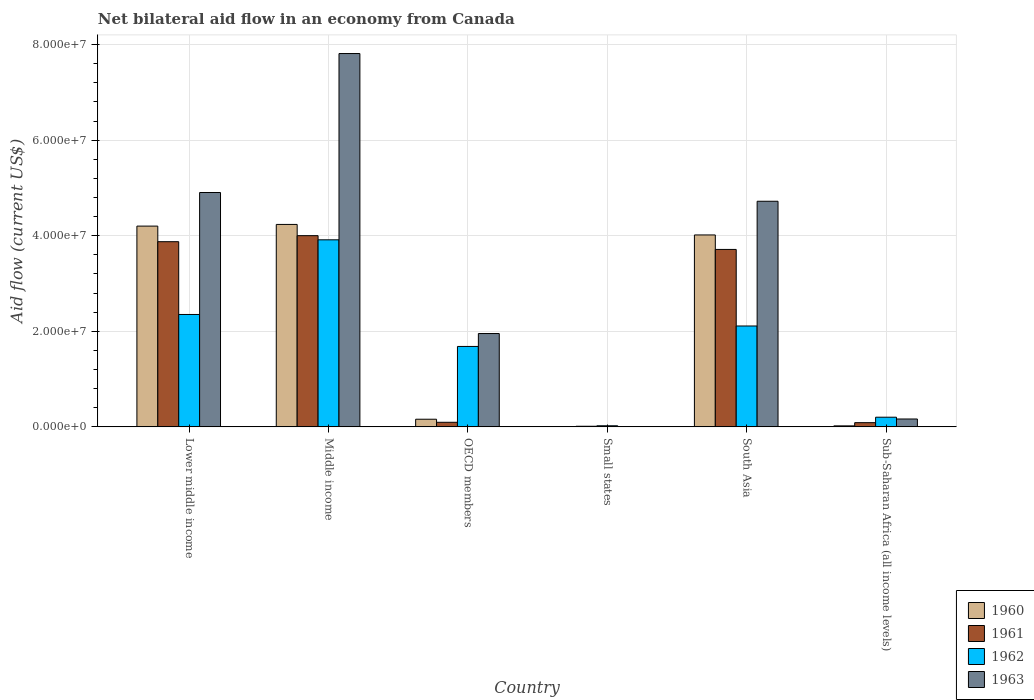How many different coloured bars are there?
Ensure brevity in your answer.  4. How many groups of bars are there?
Give a very brief answer. 6. Are the number of bars on each tick of the X-axis equal?
Provide a succinct answer. Yes. How many bars are there on the 1st tick from the left?
Provide a short and direct response. 4. How many bars are there on the 3rd tick from the right?
Offer a terse response. 4. Across all countries, what is the maximum net bilateral aid flow in 1962?
Ensure brevity in your answer.  3.91e+07. In which country was the net bilateral aid flow in 1960 maximum?
Your response must be concise. Middle income. In which country was the net bilateral aid flow in 1962 minimum?
Offer a terse response. Small states. What is the total net bilateral aid flow in 1961 in the graph?
Offer a terse response. 1.18e+08. What is the difference between the net bilateral aid flow in 1962 in South Asia and that in Sub-Saharan Africa (all income levels)?
Keep it short and to the point. 1.91e+07. What is the difference between the net bilateral aid flow in 1960 in Sub-Saharan Africa (all income levels) and the net bilateral aid flow in 1961 in OECD members?
Provide a short and direct response. -7.50e+05. What is the average net bilateral aid flow in 1962 per country?
Make the answer very short. 1.71e+07. What is the ratio of the net bilateral aid flow in 1962 in Lower middle income to that in OECD members?
Your response must be concise. 1.4. Is the difference between the net bilateral aid flow in 1960 in Lower middle income and Small states greater than the difference between the net bilateral aid flow in 1961 in Lower middle income and Small states?
Offer a terse response. Yes. What is the difference between the highest and the second highest net bilateral aid flow in 1960?
Provide a succinct answer. 2.20e+06. What is the difference between the highest and the lowest net bilateral aid flow in 1961?
Your response must be concise. 3.99e+07. Is it the case that in every country, the sum of the net bilateral aid flow in 1963 and net bilateral aid flow in 1960 is greater than the sum of net bilateral aid flow in 1962 and net bilateral aid flow in 1961?
Ensure brevity in your answer.  No. What does the 1st bar from the left in South Asia represents?
Offer a terse response. 1960. Is it the case that in every country, the sum of the net bilateral aid flow in 1963 and net bilateral aid flow in 1962 is greater than the net bilateral aid flow in 1961?
Give a very brief answer. Yes. How many countries are there in the graph?
Provide a short and direct response. 6. What is the difference between two consecutive major ticks on the Y-axis?
Offer a very short reply. 2.00e+07. Are the values on the major ticks of Y-axis written in scientific E-notation?
Your response must be concise. Yes. Does the graph contain any zero values?
Provide a short and direct response. No. Does the graph contain grids?
Your answer should be very brief. Yes. Where does the legend appear in the graph?
Make the answer very short. Bottom right. What is the title of the graph?
Your answer should be compact. Net bilateral aid flow in an economy from Canada. What is the Aid flow (current US$) of 1960 in Lower middle income?
Keep it short and to the point. 4.20e+07. What is the Aid flow (current US$) of 1961 in Lower middle income?
Your answer should be very brief. 3.88e+07. What is the Aid flow (current US$) of 1962 in Lower middle income?
Your response must be concise. 2.35e+07. What is the Aid flow (current US$) in 1963 in Lower middle income?
Offer a very short reply. 4.90e+07. What is the Aid flow (current US$) of 1960 in Middle income?
Ensure brevity in your answer.  4.24e+07. What is the Aid flow (current US$) in 1961 in Middle income?
Make the answer very short. 4.00e+07. What is the Aid flow (current US$) in 1962 in Middle income?
Your answer should be very brief. 3.91e+07. What is the Aid flow (current US$) in 1963 in Middle income?
Make the answer very short. 7.81e+07. What is the Aid flow (current US$) in 1960 in OECD members?
Provide a short and direct response. 1.60e+06. What is the Aid flow (current US$) in 1961 in OECD members?
Provide a short and direct response. 9.60e+05. What is the Aid flow (current US$) of 1962 in OECD members?
Provide a succinct answer. 1.68e+07. What is the Aid flow (current US$) in 1963 in OECD members?
Your answer should be compact. 1.95e+07. What is the Aid flow (current US$) in 1961 in Small states?
Give a very brief answer. 1.30e+05. What is the Aid flow (current US$) of 1960 in South Asia?
Make the answer very short. 4.02e+07. What is the Aid flow (current US$) in 1961 in South Asia?
Offer a very short reply. 3.71e+07. What is the Aid flow (current US$) of 1962 in South Asia?
Your response must be concise. 2.11e+07. What is the Aid flow (current US$) of 1963 in South Asia?
Offer a terse response. 4.72e+07. What is the Aid flow (current US$) of 1960 in Sub-Saharan Africa (all income levels)?
Offer a terse response. 2.10e+05. What is the Aid flow (current US$) in 1961 in Sub-Saharan Africa (all income levels)?
Make the answer very short. 8.80e+05. What is the Aid flow (current US$) in 1962 in Sub-Saharan Africa (all income levels)?
Offer a terse response. 2.02e+06. What is the Aid flow (current US$) of 1963 in Sub-Saharan Africa (all income levels)?
Your response must be concise. 1.65e+06. Across all countries, what is the maximum Aid flow (current US$) of 1960?
Provide a succinct answer. 4.24e+07. Across all countries, what is the maximum Aid flow (current US$) of 1961?
Give a very brief answer. 4.00e+07. Across all countries, what is the maximum Aid flow (current US$) in 1962?
Keep it short and to the point. 3.91e+07. Across all countries, what is the maximum Aid flow (current US$) of 1963?
Give a very brief answer. 7.81e+07. Across all countries, what is the minimum Aid flow (current US$) of 1962?
Your answer should be compact. 2.30e+05. Across all countries, what is the minimum Aid flow (current US$) in 1963?
Provide a short and direct response. 3.00e+04. What is the total Aid flow (current US$) of 1960 in the graph?
Ensure brevity in your answer.  1.26e+08. What is the total Aid flow (current US$) of 1961 in the graph?
Give a very brief answer. 1.18e+08. What is the total Aid flow (current US$) of 1962 in the graph?
Your response must be concise. 1.03e+08. What is the total Aid flow (current US$) of 1963 in the graph?
Give a very brief answer. 1.96e+08. What is the difference between the Aid flow (current US$) of 1960 in Lower middle income and that in Middle income?
Your answer should be very brief. -3.50e+05. What is the difference between the Aid flow (current US$) in 1961 in Lower middle income and that in Middle income?
Keep it short and to the point. -1.26e+06. What is the difference between the Aid flow (current US$) of 1962 in Lower middle income and that in Middle income?
Give a very brief answer. -1.56e+07. What is the difference between the Aid flow (current US$) in 1963 in Lower middle income and that in Middle income?
Provide a short and direct response. -2.91e+07. What is the difference between the Aid flow (current US$) of 1960 in Lower middle income and that in OECD members?
Provide a succinct answer. 4.04e+07. What is the difference between the Aid flow (current US$) in 1961 in Lower middle income and that in OECD members?
Keep it short and to the point. 3.78e+07. What is the difference between the Aid flow (current US$) of 1962 in Lower middle income and that in OECD members?
Your answer should be very brief. 6.69e+06. What is the difference between the Aid flow (current US$) of 1963 in Lower middle income and that in OECD members?
Offer a very short reply. 2.95e+07. What is the difference between the Aid flow (current US$) in 1960 in Lower middle income and that in Small states?
Provide a short and direct response. 4.20e+07. What is the difference between the Aid flow (current US$) of 1961 in Lower middle income and that in Small states?
Your answer should be compact. 3.86e+07. What is the difference between the Aid flow (current US$) of 1962 in Lower middle income and that in Small states?
Offer a very short reply. 2.33e+07. What is the difference between the Aid flow (current US$) in 1963 in Lower middle income and that in Small states?
Keep it short and to the point. 4.90e+07. What is the difference between the Aid flow (current US$) in 1960 in Lower middle income and that in South Asia?
Give a very brief answer. 1.85e+06. What is the difference between the Aid flow (current US$) of 1961 in Lower middle income and that in South Asia?
Your answer should be compact. 1.62e+06. What is the difference between the Aid flow (current US$) of 1962 in Lower middle income and that in South Asia?
Keep it short and to the point. 2.41e+06. What is the difference between the Aid flow (current US$) in 1963 in Lower middle income and that in South Asia?
Your response must be concise. 1.83e+06. What is the difference between the Aid flow (current US$) of 1960 in Lower middle income and that in Sub-Saharan Africa (all income levels)?
Provide a short and direct response. 4.18e+07. What is the difference between the Aid flow (current US$) of 1961 in Lower middle income and that in Sub-Saharan Africa (all income levels)?
Offer a terse response. 3.79e+07. What is the difference between the Aid flow (current US$) of 1962 in Lower middle income and that in Sub-Saharan Africa (all income levels)?
Keep it short and to the point. 2.15e+07. What is the difference between the Aid flow (current US$) in 1963 in Lower middle income and that in Sub-Saharan Africa (all income levels)?
Your response must be concise. 4.74e+07. What is the difference between the Aid flow (current US$) in 1960 in Middle income and that in OECD members?
Offer a terse response. 4.08e+07. What is the difference between the Aid flow (current US$) in 1961 in Middle income and that in OECD members?
Keep it short and to the point. 3.90e+07. What is the difference between the Aid flow (current US$) in 1962 in Middle income and that in OECD members?
Your response must be concise. 2.23e+07. What is the difference between the Aid flow (current US$) in 1963 in Middle income and that in OECD members?
Ensure brevity in your answer.  5.86e+07. What is the difference between the Aid flow (current US$) in 1960 in Middle income and that in Small states?
Provide a short and direct response. 4.23e+07. What is the difference between the Aid flow (current US$) of 1961 in Middle income and that in Small states?
Provide a succinct answer. 3.99e+07. What is the difference between the Aid flow (current US$) in 1962 in Middle income and that in Small states?
Offer a terse response. 3.89e+07. What is the difference between the Aid flow (current US$) in 1963 in Middle income and that in Small states?
Offer a very short reply. 7.81e+07. What is the difference between the Aid flow (current US$) of 1960 in Middle income and that in South Asia?
Your answer should be very brief. 2.20e+06. What is the difference between the Aid flow (current US$) in 1961 in Middle income and that in South Asia?
Ensure brevity in your answer.  2.88e+06. What is the difference between the Aid flow (current US$) in 1962 in Middle income and that in South Asia?
Ensure brevity in your answer.  1.80e+07. What is the difference between the Aid flow (current US$) of 1963 in Middle income and that in South Asia?
Your response must be concise. 3.09e+07. What is the difference between the Aid flow (current US$) in 1960 in Middle income and that in Sub-Saharan Africa (all income levels)?
Provide a succinct answer. 4.22e+07. What is the difference between the Aid flow (current US$) in 1961 in Middle income and that in Sub-Saharan Africa (all income levels)?
Offer a terse response. 3.91e+07. What is the difference between the Aid flow (current US$) of 1962 in Middle income and that in Sub-Saharan Africa (all income levels)?
Your answer should be compact. 3.71e+07. What is the difference between the Aid flow (current US$) of 1963 in Middle income and that in Sub-Saharan Africa (all income levels)?
Provide a short and direct response. 7.65e+07. What is the difference between the Aid flow (current US$) in 1960 in OECD members and that in Small states?
Your answer should be very brief. 1.58e+06. What is the difference between the Aid flow (current US$) of 1961 in OECD members and that in Small states?
Give a very brief answer. 8.30e+05. What is the difference between the Aid flow (current US$) in 1962 in OECD members and that in Small states?
Give a very brief answer. 1.66e+07. What is the difference between the Aid flow (current US$) in 1963 in OECD members and that in Small states?
Ensure brevity in your answer.  1.95e+07. What is the difference between the Aid flow (current US$) of 1960 in OECD members and that in South Asia?
Ensure brevity in your answer.  -3.86e+07. What is the difference between the Aid flow (current US$) of 1961 in OECD members and that in South Asia?
Ensure brevity in your answer.  -3.62e+07. What is the difference between the Aid flow (current US$) of 1962 in OECD members and that in South Asia?
Your answer should be very brief. -4.28e+06. What is the difference between the Aid flow (current US$) in 1963 in OECD members and that in South Asia?
Keep it short and to the point. -2.77e+07. What is the difference between the Aid flow (current US$) of 1960 in OECD members and that in Sub-Saharan Africa (all income levels)?
Keep it short and to the point. 1.39e+06. What is the difference between the Aid flow (current US$) of 1961 in OECD members and that in Sub-Saharan Africa (all income levels)?
Keep it short and to the point. 8.00e+04. What is the difference between the Aid flow (current US$) in 1962 in OECD members and that in Sub-Saharan Africa (all income levels)?
Your response must be concise. 1.48e+07. What is the difference between the Aid flow (current US$) in 1963 in OECD members and that in Sub-Saharan Africa (all income levels)?
Your answer should be very brief. 1.79e+07. What is the difference between the Aid flow (current US$) of 1960 in Small states and that in South Asia?
Make the answer very short. -4.01e+07. What is the difference between the Aid flow (current US$) of 1961 in Small states and that in South Asia?
Keep it short and to the point. -3.70e+07. What is the difference between the Aid flow (current US$) of 1962 in Small states and that in South Asia?
Keep it short and to the point. -2.09e+07. What is the difference between the Aid flow (current US$) of 1963 in Small states and that in South Asia?
Your answer should be compact. -4.72e+07. What is the difference between the Aid flow (current US$) of 1961 in Small states and that in Sub-Saharan Africa (all income levels)?
Your answer should be compact. -7.50e+05. What is the difference between the Aid flow (current US$) in 1962 in Small states and that in Sub-Saharan Africa (all income levels)?
Provide a short and direct response. -1.79e+06. What is the difference between the Aid flow (current US$) in 1963 in Small states and that in Sub-Saharan Africa (all income levels)?
Provide a short and direct response. -1.62e+06. What is the difference between the Aid flow (current US$) in 1960 in South Asia and that in Sub-Saharan Africa (all income levels)?
Offer a terse response. 4.00e+07. What is the difference between the Aid flow (current US$) of 1961 in South Asia and that in Sub-Saharan Africa (all income levels)?
Your response must be concise. 3.62e+07. What is the difference between the Aid flow (current US$) of 1962 in South Asia and that in Sub-Saharan Africa (all income levels)?
Your answer should be compact. 1.91e+07. What is the difference between the Aid flow (current US$) in 1963 in South Asia and that in Sub-Saharan Africa (all income levels)?
Make the answer very short. 4.56e+07. What is the difference between the Aid flow (current US$) in 1960 in Lower middle income and the Aid flow (current US$) in 1961 in Middle income?
Offer a very short reply. 2.00e+06. What is the difference between the Aid flow (current US$) in 1960 in Lower middle income and the Aid flow (current US$) in 1962 in Middle income?
Offer a terse response. 2.87e+06. What is the difference between the Aid flow (current US$) of 1960 in Lower middle income and the Aid flow (current US$) of 1963 in Middle income?
Give a very brief answer. -3.61e+07. What is the difference between the Aid flow (current US$) of 1961 in Lower middle income and the Aid flow (current US$) of 1962 in Middle income?
Offer a very short reply. -3.90e+05. What is the difference between the Aid flow (current US$) in 1961 in Lower middle income and the Aid flow (current US$) in 1963 in Middle income?
Provide a short and direct response. -3.94e+07. What is the difference between the Aid flow (current US$) in 1962 in Lower middle income and the Aid flow (current US$) in 1963 in Middle income?
Your answer should be very brief. -5.46e+07. What is the difference between the Aid flow (current US$) in 1960 in Lower middle income and the Aid flow (current US$) in 1961 in OECD members?
Ensure brevity in your answer.  4.10e+07. What is the difference between the Aid flow (current US$) in 1960 in Lower middle income and the Aid flow (current US$) in 1962 in OECD members?
Provide a short and direct response. 2.52e+07. What is the difference between the Aid flow (current US$) of 1960 in Lower middle income and the Aid flow (current US$) of 1963 in OECD members?
Your answer should be very brief. 2.25e+07. What is the difference between the Aid flow (current US$) in 1961 in Lower middle income and the Aid flow (current US$) in 1962 in OECD members?
Offer a terse response. 2.19e+07. What is the difference between the Aid flow (current US$) in 1961 in Lower middle income and the Aid flow (current US$) in 1963 in OECD members?
Give a very brief answer. 1.92e+07. What is the difference between the Aid flow (current US$) of 1962 in Lower middle income and the Aid flow (current US$) of 1963 in OECD members?
Provide a short and direct response. 3.99e+06. What is the difference between the Aid flow (current US$) in 1960 in Lower middle income and the Aid flow (current US$) in 1961 in Small states?
Give a very brief answer. 4.19e+07. What is the difference between the Aid flow (current US$) of 1960 in Lower middle income and the Aid flow (current US$) of 1962 in Small states?
Your answer should be very brief. 4.18e+07. What is the difference between the Aid flow (current US$) in 1960 in Lower middle income and the Aid flow (current US$) in 1963 in Small states?
Provide a short and direct response. 4.20e+07. What is the difference between the Aid flow (current US$) of 1961 in Lower middle income and the Aid flow (current US$) of 1962 in Small states?
Ensure brevity in your answer.  3.85e+07. What is the difference between the Aid flow (current US$) in 1961 in Lower middle income and the Aid flow (current US$) in 1963 in Small states?
Offer a terse response. 3.87e+07. What is the difference between the Aid flow (current US$) in 1962 in Lower middle income and the Aid flow (current US$) in 1963 in Small states?
Offer a terse response. 2.35e+07. What is the difference between the Aid flow (current US$) of 1960 in Lower middle income and the Aid flow (current US$) of 1961 in South Asia?
Provide a succinct answer. 4.88e+06. What is the difference between the Aid flow (current US$) of 1960 in Lower middle income and the Aid flow (current US$) of 1962 in South Asia?
Your answer should be compact. 2.09e+07. What is the difference between the Aid flow (current US$) of 1960 in Lower middle income and the Aid flow (current US$) of 1963 in South Asia?
Make the answer very short. -5.20e+06. What is the difference between the Aid flow (current US$) of 1961 in Lower middle income and the Aid flow (current US$) of 1962 in South Asia?
Provide a short and direct response. 1.76e+07. What is the difference between the Aid flow (current US$) of 1961 in Lower middle income and the Aid flow (current US$) of 1963 in South Asia?
Keep it short and to the point. -8.46e+06. What is the difference between the Aid flow (current US$) of 1962 in Lower middle income and the Aid flow (current US$) of 1963 in South Asia?
Offer a terse response. -2.37e+07. What is the difference between the Aid flow (current US$) of 1960 in Lower middle income and the Aid flow (current US$) of 1961 in Sub-Saharan Africa (all income levels)?
Provide a short and direct response. 4.11e+07. What is the difference between the Aid flow (current US$) in 1960 in Lower middle income and the Aid flow (current US$) in 1962 in Sub-Saharan Africa (all income levels)?
Your answer should be very brief. 4.00e+07. What is the difference between the Aid flow (current US$) in 1960 in Lower middle income and the Aid flow (current US$) in 1963 in Sub-Saharan Africa (all income levels)?
Ensure brevity in your answer.  4.04e+07. What is the difference between the Aid flow (current US$) in 1961 in Lower middle income and the Aid flow (current US$) in 1962 in Sub-Saharan Africa (all income levels)?
Offer a terse response. 3.67e+07. What is the difference between the Aid flow (current US$) in 1961 in Lower middle income and the Aid flow (current US$) in 1963 in Sub-Saharan Africa (all income levels)?
Your response must be concise. 3.71e+07. What is the difference between the Aid flow (current US$) of 1962 in Lower middle income and the Aid flow (current US$) of 1963 in Sub-Saharan Africa (all income levels)?
Your answer should be compact. 2.19e+07. What is the difference between the Aid flow (current US$) of 1960 in Middle income and the Aid flow (current US$) of 1961 in OECD members?
Give a very brief answer. 4.14e+07. What is the difference between the Aid flow (current US$) of 1960 in Middle income and the Aid flow (current US$) of 1962 in OECD members?
Offer a very short reply. 2.55e+07. What is the difference between the Aid flow (current US$) in 1960 in Middle income and the Aid flow (current US$) in 1963 in OECD members?
Offer a terse response. 2.28e+07. What is the difference between the Aid flow (current US$) of 1961 in Middle income and the Aid flow (current US$) of 1962 in OECD members?
Provide a short and direct response. 2.32e+07. What is the difference between the Aid flow (current US$) of 1961 in Middle income and the Aid flow (current US$) of 1963 in OECD members?
Ensure brevity in your answer.  2.05e+07. What is the difference between the Aid flow (current US$) of 1962 in Middle income and the Aid flow (current US$) of 1963 in OECD members?
Make the answer very short. 1.96e+07. What is the difference between the Aid flow (current US$) in 1960 in Middle income and the Aid flow (current US$) in 1961 in Small states?
Provide a succinct answer. 4.22e+07. What is the difference between the Aid flow (current US$) in 1960 in Middle income and the Aid flow (current US$) in 1962 in Small states?
Provide a succinct answer. 4.21e+07. What is the difference between the Aid flow (current US$) of 1960 in Middle income and the Aid flow (current US$) of 1963 in Small states?
Your answer should be very brief. 4.23e+07. What is the difference between the Aid flow (current US$) in 1961 in Middle income and the Aid flow (current US$) in 1962 in Small states?
Ensure brevity in your answer.  3.98e+07. What is the difference between the Aid flow (current US$) in 1961 in Middle income and the Aid flow (current US$) in 1963 in Small states?
Provide a succinct answer. 4.00e+07. What is the difference between the Aid flow (current US$) of 1962 in Middle income and the Aid flow (current US$) of 1963 in Small states?
Your answer should be compact. 3.91e+07. What is the difference between the Aid flow (current US$) of 1960 in Middle income and the Aid flow (current US$) of 1961 in South Asia?
Make the answer very short. 5.23e+06. What is the difference between the Aid flow (current US$) in 1960 in Middle income and the Aid flow (current US$) in 1962 in South Asia?
Keep it short and to the point. 2.12e+07. What is the difference between the Aid flow (current US$) in 1960 in Middle income and the Aid flow (current US$) in 1963 in South Asia?
Offer a very short reply. -4.85e+06. What is the difference between the Aid flow (current US$) of 1961 in Middle income and the Aid flow (current US$) of 1962 in South Asia?
Ensure brevity in your answer.  1.89e+07. What is the difference between the Aid flow (current US$) in 1961 in Middle income and the Aid flow (current US$) in 1963 in South Asia?
Give a very brief answer. -7.20e+06. What is the difference between the Aid flow (current US$) in 1962 in Middle income and the Aid flow (current US$) in 1963 in South Asia?
Provide a short and direct response. -8.07e+06. What is the difference between the Aid flow (current US$) of 1960 in Middle income and the Aid flow (current US$) of 1961 in Sub-Saharan Africa (all income levels)?
Your response must be concise. 4.15e+07. What is the difference between the Aid flow (current US$) in 1960 in Middle income and the Aid flow (current US$) in 1962 in Sub-Saharan Africa (all income levels)?
Your answer should be very brief. 4.03e+07. What is the difference between the Aid flow (current US$) of 1960 in Middle income and the Aid flow (current US$) of 1963 in Sub-Saharan Africa (all income levels)?
Make the answer very short. 4.07e+07. What is the difference between the Aid flow (current US$) of 1961 in Middle income and the Aid flow (current US$) of 1962 in Sub-Saharan Africa (all income levels)?
Your answer should be compact. 3.80e+07. What is the difference between the Aid flow (current US$) in 1961 in Middle income and the Aid flow (current US$) in 1963 in Sub-Saharan Africa (all income levels)?
Ensure brevity in your answer.  3.84e+07. What is the difference between the Aid flow (current US$) of 1962 in Middle income and the Aid flow (current US$) of 1963 in Sub-Saharan Africa (all income levels)?
Your answer should be very brief. 3.75e+07. What is the difference between the Aid flow (current US$) in 1960 in OECD members and the Aid flow (current US$) in 1961 in Small states?
Offer a very short reply. 1.47e+06. What is the difference between the Aid flow (current US$) in 1960 in OECD members and the Aid flow (current US$) in 1962 in Small states?
Keep it short and to the point. 1.37e+06. What is the difference between the Aid flow (current US$) of 1960 in OECD members and the Aid flow (current US$) of 1963 in Small states?
Your answer should be very brief. 1.57e+06. What is the difference between the Aid flow (current US$) in 1961 in OECD members and the Aid flow (current US$) in 1962 in Small states?
Your response must be concise. 7.30e+05. What is the difference between the Aid flow (current US$) of 1961 in OECD members and the Aid flow (current US$) of 1963 in Small states?
Your response must be concise. 9.30e+05. What is the difference between the Aid flow (current US$) of 1962 in OECD members and the Aid flow (current US$) of 1963 in Small states?
Your response must be concise. 1.68e+07. What is the difference between the Aid flow (current US$) in 1960 in OECD members and the Aid flow (current US$) in 1961 in South Asia?
Your answer should be compact. -3.55e+07. What is the difference between the Aid flow (current US$) of 1960 in OECD members and the Aid flow (current US$) of 1962 in South Asia?
Ensure brevity in your answer.  -1.95e+07. What is the difference between the Aid flow (current US$) in 1960 in OECD members and the Aid flow (current US$) in 1963 in South Asia?
Give a very brief answer. -4.56e+07. What is the difference between the Aid flow (current US$) of 1961 in OECD members and the Aid flow (current US$) of 1962 in South Asia?
Offer a very short reply. -2.02e+07. What is the difference between the Aid flow (current US$) in 1961 in OECD members and the Aid flow (current US$) in 1963 in South Asia?
Your response must be concise. -4.62e+07. What is the difference between the Aid flow (current US$) in 1962 in OECD members and the Aid flow (current US$) in 1963 in South Asia?
Provide a short and direct response. -3.04e+07. What is the difference between the Aid flow (current US$) of 1960 in OECD members and the Aid flow (current US$) of 1961 in Sub-Saharan Africa (all income levels)?
Give a very brief answer. 7.20e+05. What is the difference between the Aid flow (current US$) in 1960 in OECD members and the Aid flow (current US$) in 1962 in Sub-Saharan Africa (all income levels)?
Your answer should be compact. -4.20e+05. What is the difference between the Aid flow (current US$) of 1960 in OECD members and the Aid flow (current US$) of 1963 in Sub-Saharan Africa (all income levels)?
Your answer should be compact. -5.00e+04. What is the difference between the Aid flow (current US$) of 1961 in OECD members and the Aid flow (current US$) of 1962 in Sub-Saharan Africa (all income levels)?
Give a very brief answer. -1.06e+06. What is the difference between the Aid flow (current US$) of 1961 in OECD members and the Aid flow (current US$) of 1963 in Sub-Saharan Africa (all income levels)?
Your answer should be compact. -6.90e+05. What is the difference between the Aid flow (current US$) in 1962 in OECD members and the Aid flow (current US$) in 1963 in Sub-Saharan Africa (all income levels)?
Provide a succinct answer. 1.52e+07. What is the difference between the Aid flow (current US$) of 1960 in Small states and the Aid flow (current US$) of 1961 in South Asia?
Keep it short and to the point. -3.71e+07. What is the difference between the Aid flow (current US$) of 1960 in Small states and the Aid flow (current US$) of 1962 in South Asia?
Provide a short and direct response. -2.11e+07. What is the difference between the Aid flow (current US$) of 1960 in Small states and the Aid flow (current US$) of 1963 in South Asia?
Your response must be concise. -4.72e+07. What is the difference between the Aid flow (current US$) in 1961 in Small states and the Aid flow (current US$) in 1962 in South Asia?
Offer a terse response. -2.10e+07. What is the difference between the Aid flow (current US$) in 1961 in Small states and the Aid flow (current US$) in 1963 in South Asia?
Provide a short and direct response. -4.71e+07. What is the difference between the Aid flow (current US$) in 1962 in Small states and the Aid flow (current US$) in 1963 in South Asia?
Give a very brief answer. -4.70e+07. What is the difference between the Aid flow (current US$) in 1960 in Small states and the Aid flow (current US$) in 1961 in Sub-Saharan Africa (all income levels)?
Keep it short and to the point. -8.60e+05. What is the difference between the Aid flow (current US$) of 1960 in Small states and the Aid flow (current US$) of 1962 in Sub-Saharan Africa (all income levels)?
Provide a succinct answer. -2.00e+06. What is the difference between the Aid flow (current US$) in 1960 in Small states and the Aid flow (current US$) in 1963 in Sub-Saharan Africa (all income levels)?
Your answer should be compact. -1.63e+06. What is the difference between the Aid flow (current US$) of 1961 in Small states and the Aid flow (current US$) of 1962 in Sub-Saharan Africa (all income levels)?
Your answer should be very brief. -1.89e+06. What is the difference between the Aid flow (current US$) of 1961 in Small states and the Aid flow (current US$) of 1963 in Sub-Saharan Africa (all income levels)?
Provide a short and direct response. -1.52e+06. What is the difference between the Aid flow (current US$) in 1962 in Small states and the Aid flow (current US$) in 1963 in Sub-Saharan Africa (all income levels)?
Offer a very short reply. -1.42e+06. What is the difference between the Aid flow (current US$) in 1960 in South Asia and the Aid flow (current US$) in 1961 in Sub-Saharan Africa (all income levels)?
Keep it short and to the point. 3.93e+07. What is the difference between the Aid flow (current US$) of 1960 in South Asia and the Aid flow (current US$) of 1962 in Sub-Saharan Africa (all income levels)?
Your response must be concise. 3.81e+07. What is the difference between the Aid flow (current US$) of 1960 in South Asia and the Aid flow (current US$) of 1963 in Sub-Saharan Africa (all income levels)?
Your response must be concise. 3.85e+07. What is the difference between the Aid flow (current US$) of 1961 in South Asia and the Aid flow (current US$) of 1962 in Sub-Saharan Africa (all income levels)?
Offer a terse response. 3.51e+07. What is the difference between the Aid flow (current US$) in 1961 in South Asia and the Aid flow (current US$) in 1963 in Sub-Saharan Africa (all income levels)?
Ensure brevity in your answer.  3.55e+07. What is the difference between the Aid flow (current US$) of 1962 in South Asia and the Aid flow (current US$) of 1963 in Sub-Saharan Africa (all income levels)?
Make the answer very short. 1.95e+07. What is the average Aid flow (current US$) in 1960 per country?
Provide a short and direct response. 2.11e+07. What is the average Aid flow (current US$) of 1961 per country?
Offer a very short reply. 1.96e+07. What is the average Aid flow (current US$) in 1962 per country?
Make the answer very short. 1.71e+07. What is the average Aid flow (current US$) in 1963 per country?
Ensure brevity in your answer.  3.26e+07. What is the difference between the Aid flow (current US$) of 1960 and Aid flow (current US$) of 1961 in Lower middle income?
Provide a succinct answer. 3.26e+06. What is the difference between the Aid flow (current US$) of 1960 and Aid flow (current US$) of 1962 in Lower middle income?
Offer a very short reply. 1.85e+07. What is the difference between the Aid flow (current US$) in 1960 and Aid flow (current US$) in 1963 in Lower middle income?
Your answer should be very brief. -7.03e+06. What is the difference between the Aid flow (current US$) in 1961 and Aid flow (current US$) in 1962 in Lower middle income?
Make the answer very short. 1.52e+07. What is the difference between the Aid flow (current US$) of 1961 and Aid flow (current US$) of 1963 in Lower middle income?
Keep it short and to the point. -1.03e+07. What is the difference between the Aid flow (current US$) of 1962 and Aid flow (current US$) of 1963 in Lower middle income?
Provide a succinct answer. -2.55e+07. What is the difference between the Aid flow (current US$) of 1960 and Aid flow (current US$) of 1961 in Middle income?
Offer a very short reply. 2.35e+06. What is the difference between the Aid flow (current US$) of 1960 and Aid flow (current US$) of 1962 in Middle income?
Your answer should be compact. 3.22e+06. What is the difference between the Aid flow (current US$) in 1960 and Aid flow (current US$) in 1963 in Middle income?
Offer a terse response. -3.58e+07. What is the difference between the Aid flow (current US$) in 1961 and Aid flow (current US$) in 1962 in Middle income?
Your response must be concise. 8.70e+05. What is the difference between the Aid flow (current US$) in 1961 and Aid flow (current US$) in 1963 in Middle income?
Keep it short and to the point. -3.81e+07. What is the difference between the Aid flow (current US$) of 1962 and Aid flow (current US$) of 1963 in Middle income?
Make the answer very short. -3.90e+07. What is the difference between the Aid flow (current US$) of 1960 and Aid flow (current US$) of 1961 in OECD members?
Give a very brief answer. 6.40e+05. What is the difference between the Aid flow (current US$) of 1960 and Aid flow (current US$) of 1962 in OECD members?
Give a very brief answer. -1.52e+07. What is the difference between the Aid flow (current US$) of 1960 and Aid flow (current US$) of 1963 in OECD members?
Ensure brevity in your answer.  -1.79e+07. What is the difference between the Aid flow (current US$) of 1961 and Aid flow (current US$) of 1962 in OECD members?
Your response must be concise. -1.59e+07. What is the difference between the Aid flow (current US$) in 1961 and Aid flow (current US$) in 1963 in OECD members?
Provide a short and direct response. -1.86e+07. What is the difference between the Aid flow (current US$) of 1962 and Aid flow (current US$) of 1963 in OECD members?
Offer a very short reply. -2.70e+06. What is the difference between the Aid flow (current US$) in 1960 and Aid flow (current US$) in 1962 in Small states?
Provide a short and direct response. -2.10e+05. What is the difference between the Aid flow (current US$) of 1960 and Aid flow (current US$) of 1963 in Small states?
Your answer should be very brief. -10000. What is the difference between the Aid flow (current US$) in 1960 and Aid flow (current US$) in 1961 in South Asia?
Your answer should be very brief. 3.03e+06. What is the difference between the Aid flow (current US$) of 1960 and Aid flow (current US$) of 1962 in South Asia?
Keep it short and to the point. 1.90e+07. What is the difference between the Aid flow (current US$) of 1960 and Aid flow (current US$) of 1963 in South Asia?
Ensure brevity in your answer.  -7.05e+06. What is the difference between the Aid flow (current US$) in 1961 and Aid flow (current US$) in 1962 in South Asia?
Your answer should be very brief. 1.60e+07. What is the difference between the Aid flow (current US$) in 1961 and Aid flow (current US$) in 1963 in South Asia?
Offer a terse response. -1.01e+07. What is the difference between the Aid flow (current US$) of 1962 and Aid flow (current US$) of 1963 in South Asia?
Offer a very short reply. -2.61e+07. What is the difference between the Aid flow (current US$) of 1960 and Aid flow (current US$) of 1961 in Sub-Saharan Africa (all income levels)?
Offer a very short reply. -6.70e+05. What is the difference between the Aid flow (current US$) in 1960 and Aid flow (current US$) in 1962 in Sub-Saharan Africa (all income levels)?
Your answer should be compact. -1.81e+06. What is the difference between the Aid flow (current US$) of 1960 and Aid flow (current US$) of 1963 in Sub-Saharan Africa (all income levels)?
Offer a very short reply. -1.44e+06. What is the difference between the Aid flow (current US$) of 1961 and Aid flow (current US$) of 1962 in Sub-Saharan Africa (all income levels)?
Your response must be concise. -1.14e+06. What is the difference between the Aid flow (current US$) in 1961 and Aid flow (current US$) in 1963 in Sub-Saharan Africa (all income levels)?
Offer a terse response. -7.70e+05. What is the ratio of the Aid flow (current US$) in 1961 in Lower middle income to that in Middle income?
Ensure brevity in your answer.  0.97. What is the ratio of the Aid flow (current US$) of 1962 in Lower middle income to that in Middle income?
Keep it short and to the point. 0.6. What is the ratio of the Aid flow (current US$) in 1963 in Lower middle income to that in Middle income?
Give a very brief answer. 0.63. What is the ratio of the Aid flow (current US$) in 1960 in Lower middle income to that in OECD members?
Your answer should be compact. 26.26. What is the ratio of the Aid flow (current US$) of 1961 in Lower middle income to that in OECD members?
Give a very brief answer. 40.36. What is the ratio of the Aid flow (current US$) of 1962 in Lower middle income to that in OECD members?
Ensure brevity in your answer.  1.4. What is the ratio of the Aid flow (current US$) of 1963 in Lower middle income to that in OECD members?
Make the answer very short. 2.51. What is the ratio of the Aid flow (current US$) in 1960 in Lower middle income to that in Small states?
Keep it short and to the point. 2100.5. What is the ratio of the Aid flow (current US$) of 1961 in Lower middle income to that in Small states?
Give a very brief answer. 298.08. What is the ratio of the Aid flow (current US$) in 1962 in Lower middle income to that in Small states?
Provide a succinct answer. 102.26. What is the ratio of the Aid flow (current US$) in 1963 in Lower middle income to that in Small states?
Give a very brief answer. 1634.67. What is the ratio of the Aid flow (current US$) in 1960 in Lower middle income to that in South Asia?
Provide a succinct answer. 1.05. What is the ratio of the Aid flow (current US$) of 1961 in Lower middle income to that in South Asia?
Provide a succinct answer. 1.04. What is the ratio of the Aid flow (current US$) of 1962 in Lower middle income to that in South Asia?
Provide a succinct answer. 1.11. What is the ratio of the Aid flow (current US$) of 1963 in Lower middle income to that in South Asia?
Give a very brief answer. 1.04. What is the ratio of the Aid flow (current US$) of 1960 in Lower middle income to that in Sub-Saharan Africa (all income levels)?
Offer a very short reply. 200.05. What is the ratio of the Aid flow (current US$) in 1961 in Lower middle income to that in Sub-Saharan Africa (all income levels)?
Provide a succinct answer. 44.03. What is the ratio of the Aid flow (current US$) in 1962 in Lower middle income to that in Sub-Saharan Africa (all income levels)?
Ensure brevity in your answer.  11.64. What is the ratio of the Aid flow (current US$) in 1963 in Lower middle income to that in Sub-Saharan Africa (all income levels)?
Give a very brief answer. 29.72. What is the ratio of the Aid flow (current US$) in 1960 in Middle income to that in OECD members?
Provide a succinct answer. 26.48. What is the ratio of the Aid flow (current US$) of 1961 in Middle income to that in OECD members?
Offer a terse response. 41.68. What is the ratio of the Aid flow (current US$) in 1962 in Middle income to that in OECD members?
Offer a very short reply. 2.33. What is the ratio of the Aid flow (current US$) of 1960 in Middle income to that in Small states?
Provide a succinct answer. 2118. What is the ratio of the Aid flow (current US$) of 1961 in Middle income to that in Small states?
Offer a very short reply. 307.77. What is the ratio of the Aid flow (current US$) in 1962 in Middle income to that in Small states?
Offer a very short reply. 170.17. What is the ratio of the Aid flow (current US$) in 1963 in Middle income to that in Small states?
Your response must be concise. 2604. What is the ratio of the Aid flow (current US$) of 1960 in Middle income to that in South Asia?
Keep it short and to the point. 1.05. What is the ratio of the Aid flow (current US$) in 1961 in Middle income to that in South Asia?
Ensure brevity in your answer.  1.08. What is the ratio of the Aid flow (current US$) in 1962 in Middle income to that in South Asia?
Provide a succinct answer. 1.85. What is the ratio of the Aid flow (current US$) in 1963 in Middle income to that in South Asia?
Give a very brief answer. 1.65. What is the ratio of the Aid flow (current US$) in 1960 in Middle income to that in Sub-Saharan Africa (all income levels)?
Your answer should be compact. 201.71. What is the ratio of the Aid flow (current US$) of 1961 in Middle income to that in Sub-Saharan Africa (all income levels)?
Keep it short and to the point. 45.47. What is the ratio of the Aid flow (current US$) of 1962 in Middle income to that in Sub-Saharan Africa (all income levels)?
Keep it short and to the point. 19.38. What is the ratio of the Aid flow (current US$) of 1963 in Middle income to that in Sub-Saharan Africa (all income levels)?
Provide a succinct answer. 47.35. What is the ratio of the Aid flow (current US$) in 1960 in OECD members to that in Small states?
Keep it short and to the point. 80. What is the ratio of the Aid flow (current US$) in 1961 in OECD members to that in Small states?
Provide a succinct answer. 7.38. What is the ratio of the Aid flow (current US$) of 1962 in OECD members to that in Small states?
Ensure brevity in your answer.  73.17. What is the ratio of the Aid flow (current US$) in 1963 in OECD members to that in Small states?
Ensure brevity in your answer.  651. What is the ratio of the Aid flow (current US$) in 1960 in OECD members to that in South Asia?
Offer a terse response. 0.04. What is the ratio of the Aid flow (current US$) of 1961 in OECD members to that in South Asia?
Ensure brevity in your answer.  0.03. What is the ratio of the Aid flow (current US$) of 1962 in OECD members to that in South Asia?
Offer a terse response. 0.8. What is the ratio of the Aid flow (current US$) in 1963 in OECD members to that in South Asia?
Keep it short and to the point. 0.41. What is the ratio of the Aid flow (current US$) of 1960 in OECD members to that in Sub-Saharan Africa (all income levels)?
Provide a succinct answer. 7.62. What is the ratio of the Aid flow (current US$) of 1962 in OECD members to that in Sub-Saharan Africa (all income levels)?
Make the answer very short. 8.33. What is the ratio of the Aid flow (current US$) in 1963 in OECD members to that in Sub-Saharan Africa (all income levels)?
Ensure brevity in your answer.  11.84. What is the ratio of the Aid flow (current US$) in 1961 in Small states to that in South Asia?
Offer a very short reply. 0. What is the ratio of the Aid flow (current US$) of 1962 in Small states to that in South Asia?
Your answer should be compact. 0.01. What is the ratio of the Aid flow (current US$) in 1963 in Small states to that in South Asia?
Offer a very short reply. 0. What is the ratio of the Aid flow (current US$) of 1960 in Small states to that in Sub-Saharan Africa (all income levels)?
Ensure brevity in your answer.  0.1. What is the ratio of the Aid flow (current US$) of 1961 in Small states to that in Sub-Saharan Africa (all income levels)?
Your response must be concise. 0.15. What is the ratio of the Aid flow (current US$) of 1962 in Small states to that in Sub-Saharan Africa (all income levels)?
Ensure brevity in your answer.  0.11. What is the ratio of the Aid flow (current US$) of 1963 in Small states to that in Sub-Saharan Africa (all income levels)?
Make the answer very short. 0.02. What is the ratio of the Aid flow (current US$) of 1960 in South Asia to that in Sub-Saharan Africa (all income levels)?
Offer a very short reply. 191.24. What is the ratio of the Aid flow (current US$) in 1961 in South Asia to that in Sub-Saharan Africa (all income levels)?
Provide a succinct answer. 42.19. What is the ratio of the Aid flow (current US$) of 1962 in South Asia to that in Sub-Saharan Africa (all income levels)?
Make the answer very short. 10.45. What is the ratio of the Aid flow (current US$) of 1963 in South Asia to that in Sub-Saharan Africa (all income levels)?
Provide a succinct answer. 28.61. What is the difference between the highest and the second highest Aid flow (current US$) of 1961?
Offer a very short reply. 1.26e+06. What is the difference between the highest and the second highest Aid flow (current US$) in 1962?
Your answer should be compact. 1.56e+07. What is the difference between the highest and the second highest Aid flow (current US$) in 1963?
Your answer should be very brief. 2.91e+07. What is the difference between the highest and the lowest Aid flow (current US$) of 1960?
Make the answer very short. 4.23e+07. What is the difference between the highest and the lowest Aid flow (current US$) in 1961?
Keep it short and to the point. 3.99e+07. What is the difference between the highest and the lowest Aid flow (current US$) in 1962?
Keep it short and to the point. 3.89e+07. What is the difference between the highest and the lowest Aid flow (current US$) of 1963?
Ensure brevity in your answer.  7.81e+07. 